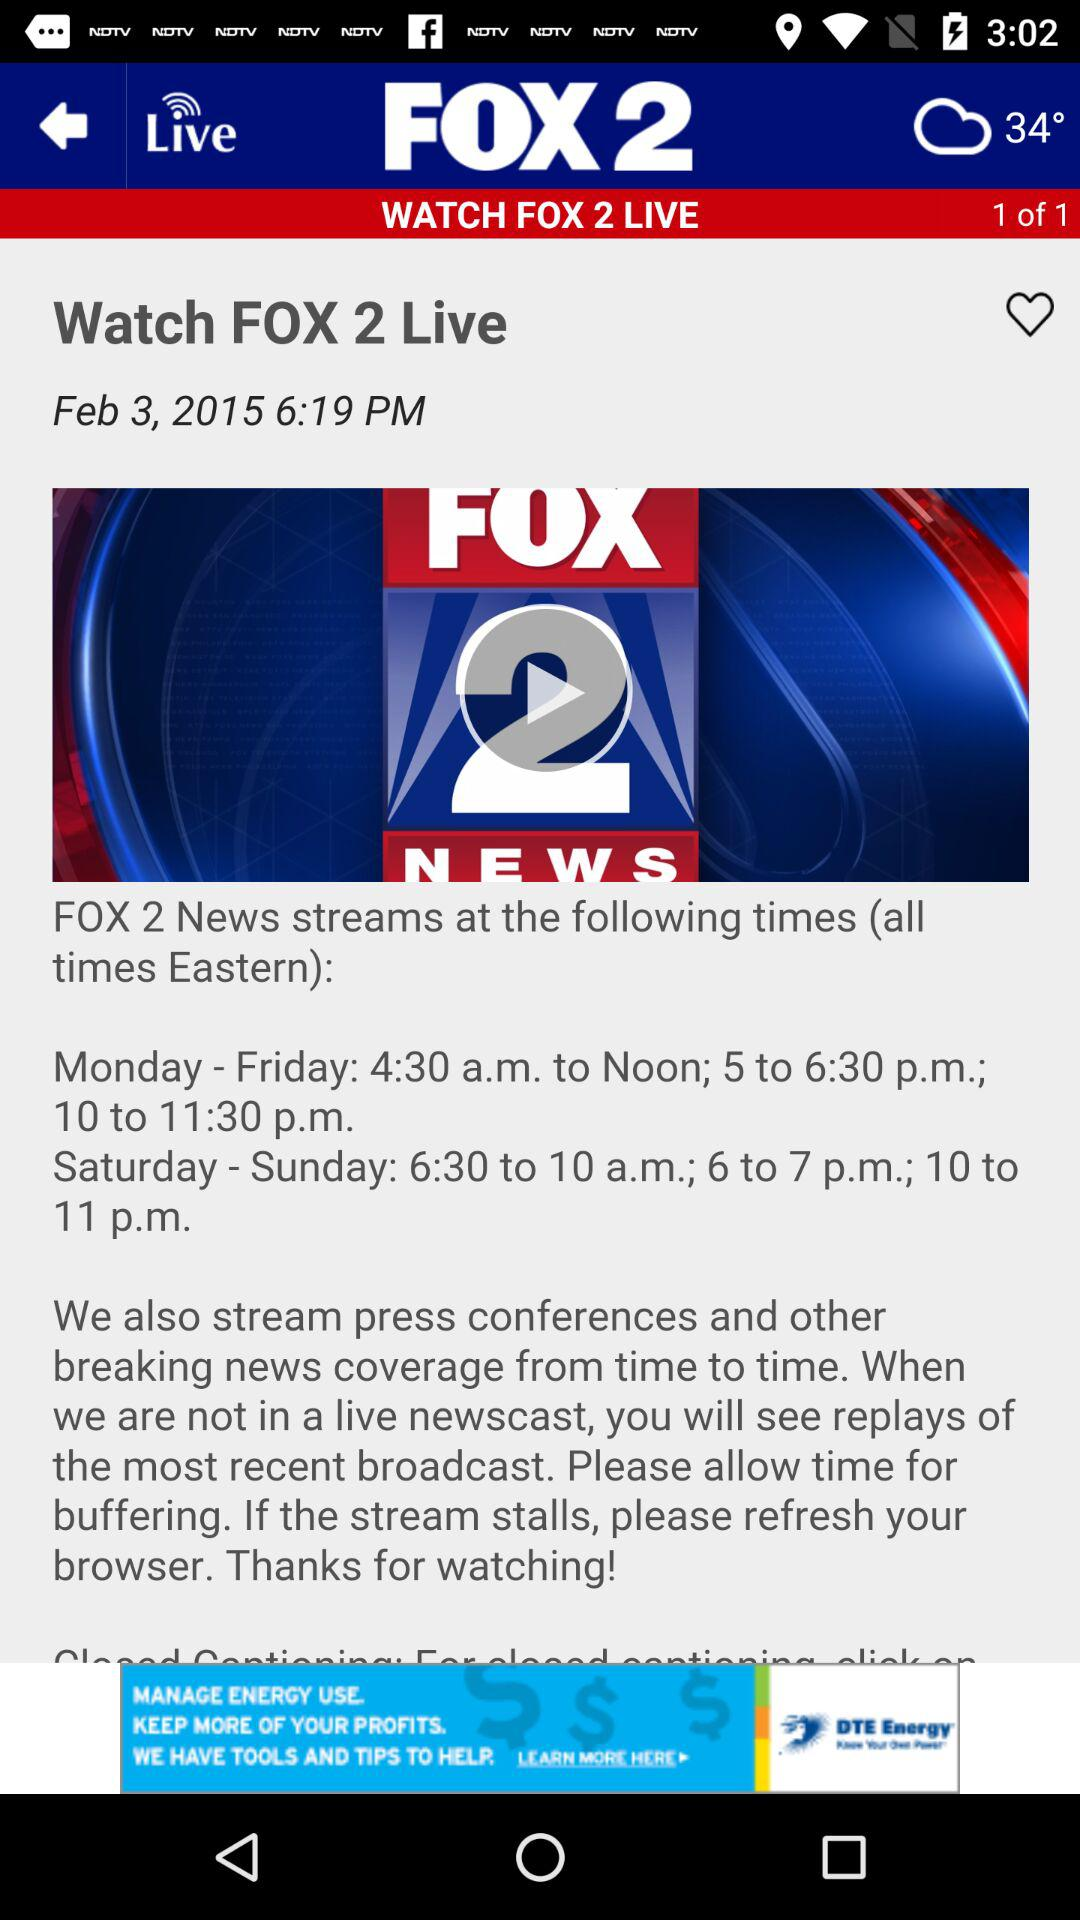What is the publication date and time? The publication date is February 3, 2015 and the time is 6:19 p.m. 